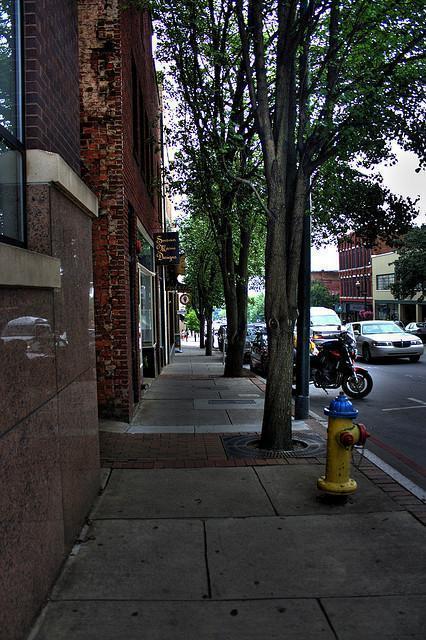What is the yellow object on the sidewalk connected to?
From the following set of four choices, select the accurate answer to respond to the question.
Options: Wall, water lines, mayor, police. Water lines. 